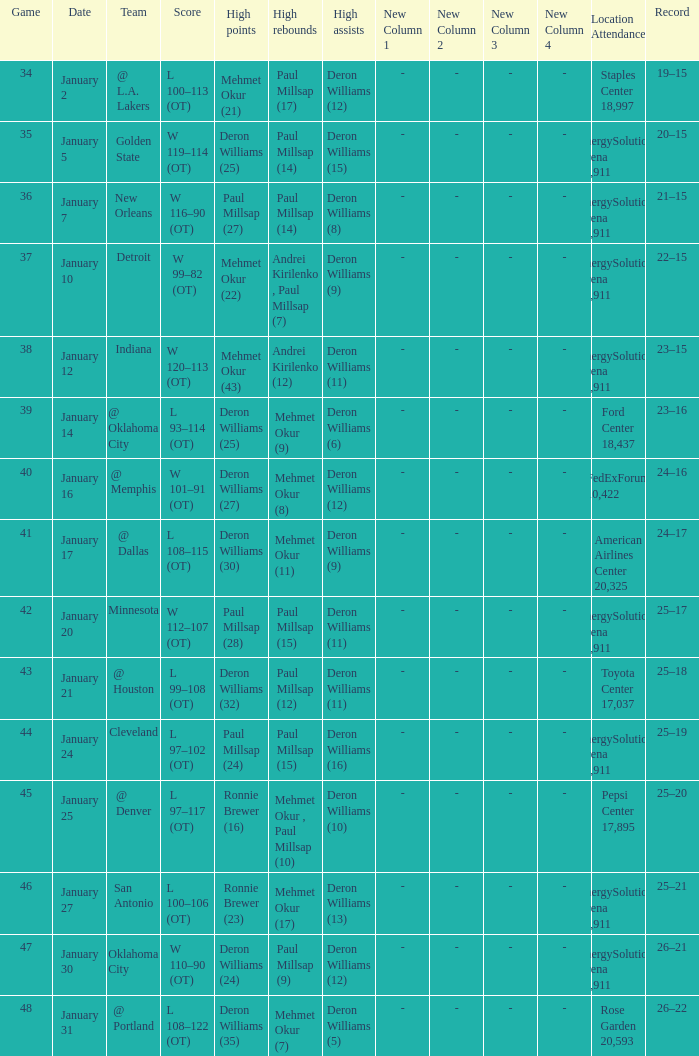Who had the high rebounds on January 24? Paul Millsap (15). 